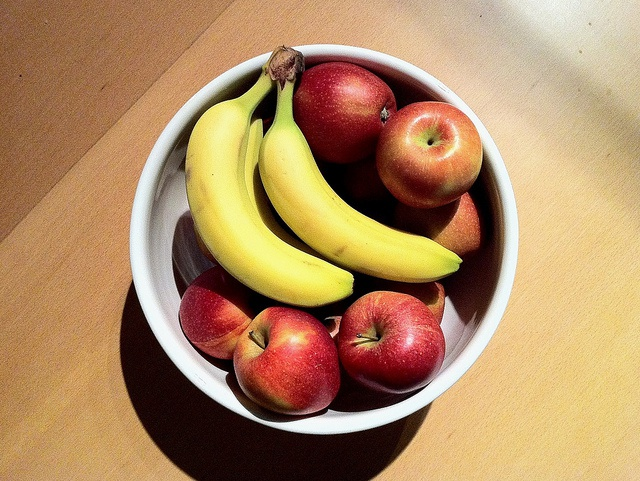Describe the objects in this image and their specific colors. I can see bowl in brown, black, khaki, white, and maroon tones, apple in brown, salmon, maroon, and black tones, apple in brown, salmon, maroon, and orange tones, apple in brown, maroon, tan, and salmon tones, and apple in brown, maroon, black, and salmon tones in this image. 